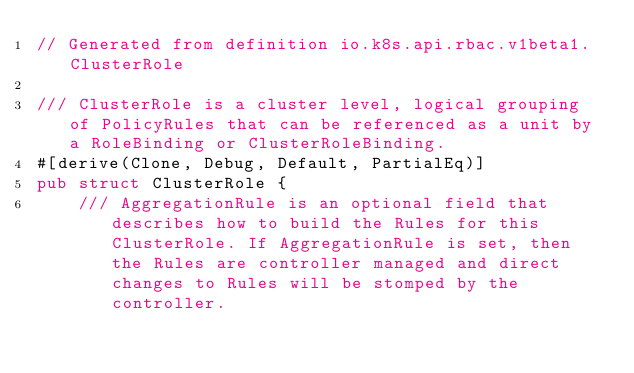<code> <loc_0><loc_0><loc_500><loc_500><_Rust_>// Generated from definition io.k8s.api.rbac.v1beta1.ClusterRole

/// ClusterRole is a cluster level, logical grouping of PolicyRules that can be referenced as a unit by a RoleBinding or ClusterRoleBinding.
#[derive(Clone, Debug, Default, PartialEq)]
pub struct ClusterRole {
    /// AggregationRule is an optional field that describes how to build the Rules for this ClusterRole. If AggregationRule is set, then the Rules are controller managed and direct changes to Rules will be stomped by the controller.</code> 